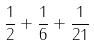<formula> <loc_0><loc_0><loc_500><loc_500>\frac { 1 } { 2 } + \frac { 1 } { 6 } + \frac { 1 } { 2 1 }</formula> 